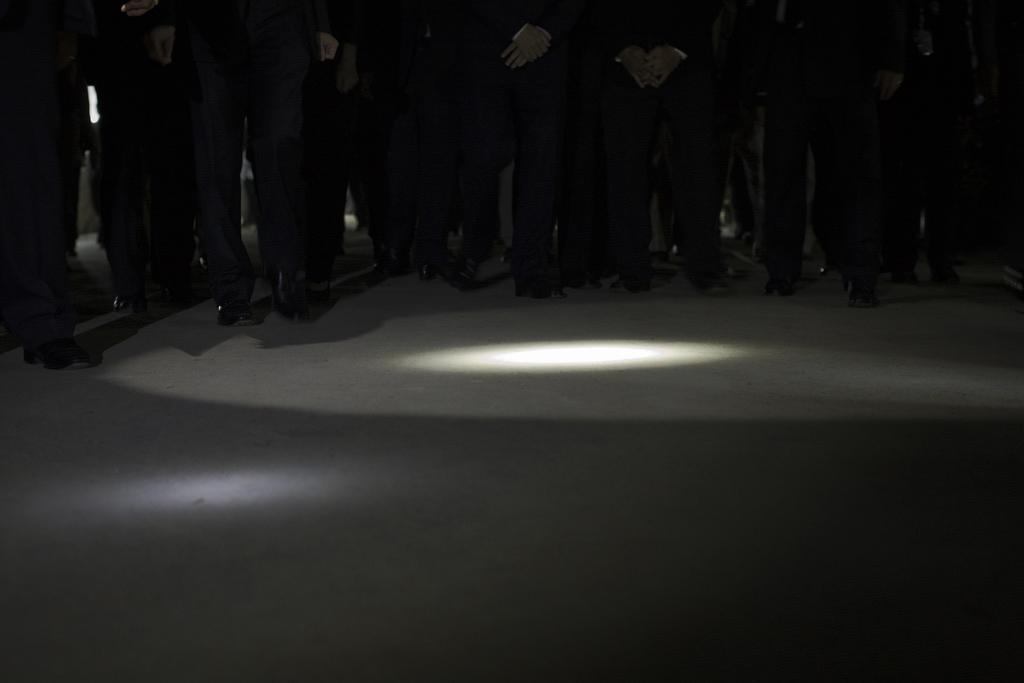Please provide a concise description of this image. In this image we can see many people wearing shoes. Also there is a light. 